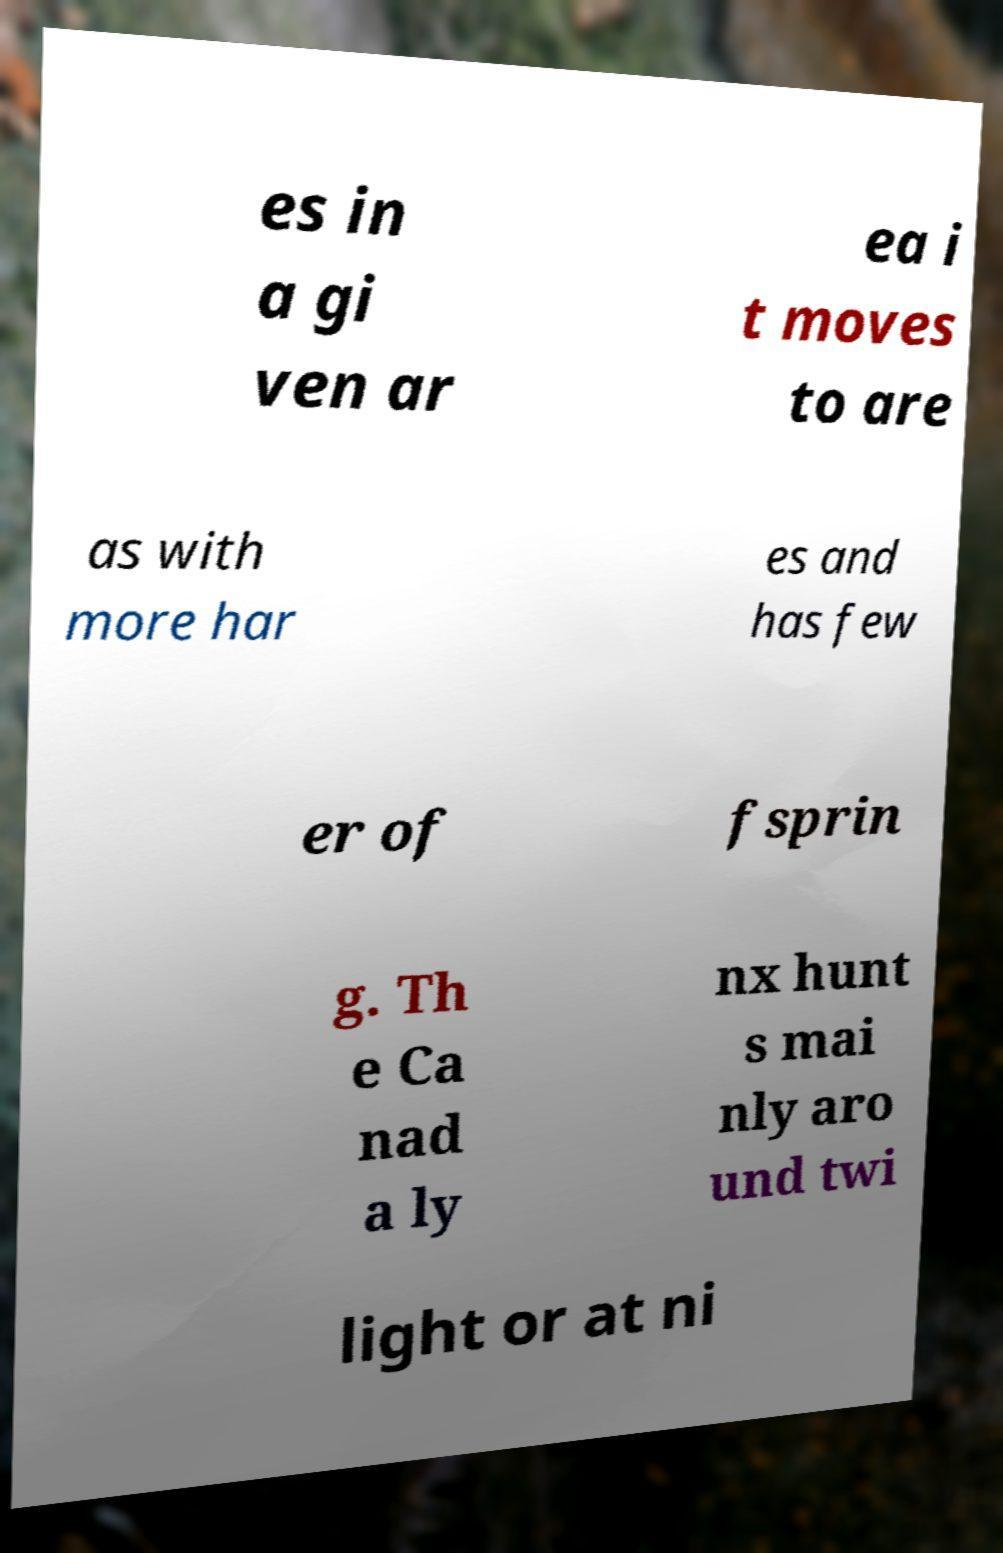Please read and relay the text visible in this image. What does it say? es in a gi ven ar ea i t moves to are as with more har es and has few er of fsprin g. Th e Ca nad a ly nx hunt s mai nly aro und twi light or at ni 